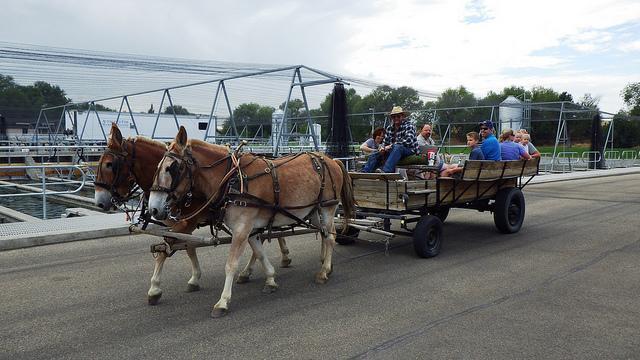How many horses are in the photo?
Give a very brief answer. 3. 